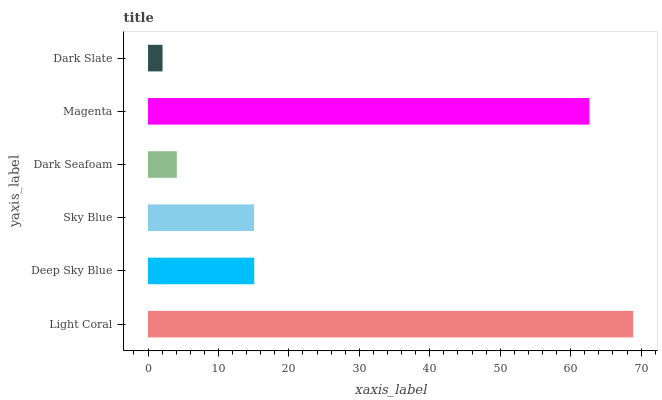Is Dark Slate the minimum?
Answer yes or no. Yes. Is Light Coral the maximum?
Answer yes or no. Yes. Is Deep Sky Blue the minimum?
Answer yes or no. No. Is Deep Sky Blue the maximum?
Answer yes or no. No. Is Light Coral greater than Deep Sky Blue?
Answer yes or no. Yes. Is Deep Sky Blue less than Light Coral?
Answer yes or no. Yes. Is Deep Sky Blue greater than Light Coral?
Answer yes or no. No. Is Light Coral less than Deep Sky Blue?
Answer yes or no. No. Is Deep Sky Blue the high median?
Answer yes or no. Yes. Is Sky Blue the low median?
Answer yes or no. Yes. Is Light Coral the high median?
Answer yes or no. No. Is Light Coral the low median?
Answer yes or no. No. 